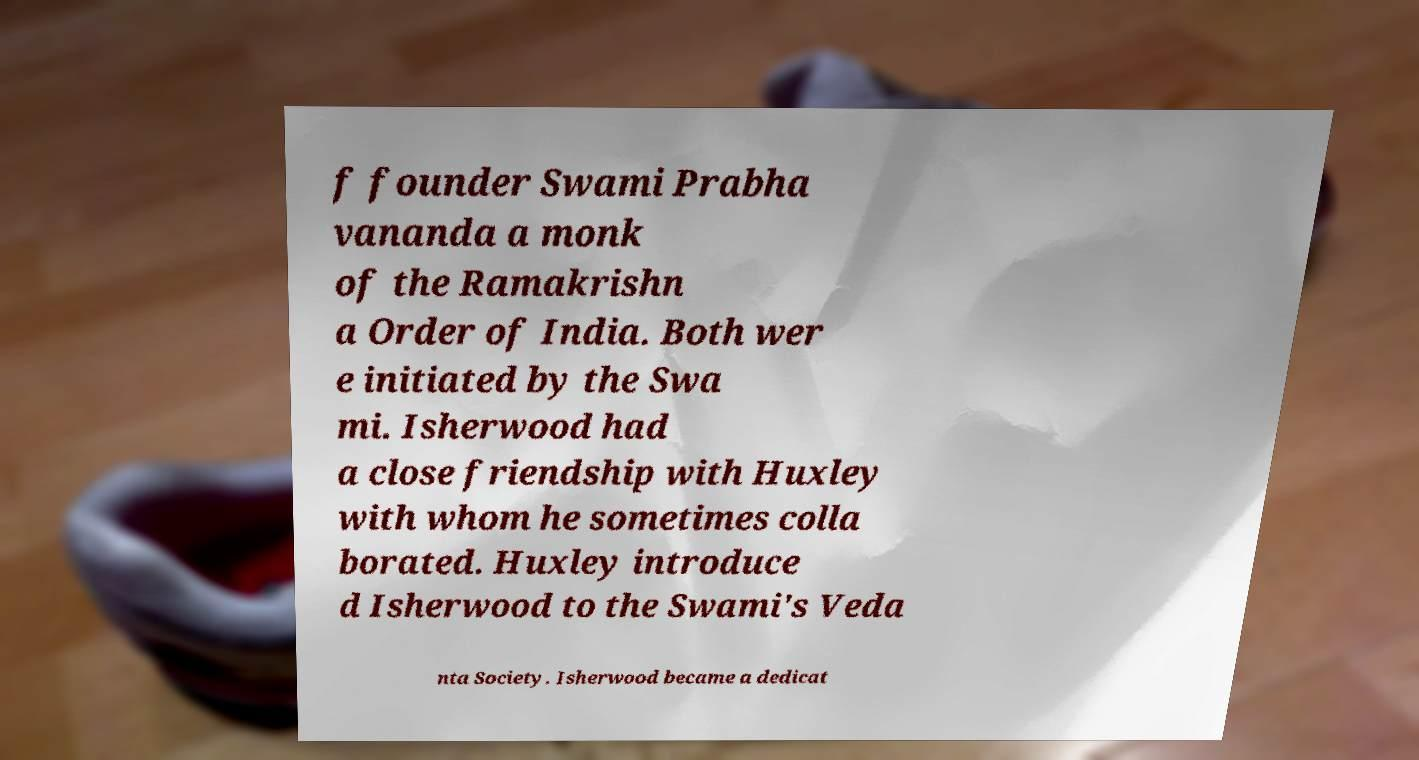There's text embedded in this image that I need extracted. Can you transcribe it verbatim? f founder Swami Prabha vananda a monk of the Ramakrishn a Order of India. Both wer e initiated by the Swa mi. Isherwood had a close friendship with Huxley with whom he sometimes colla borated. Huxley introduce d Isherwood to the Swami's Veda nta Society. Isherwood became a dedicat 